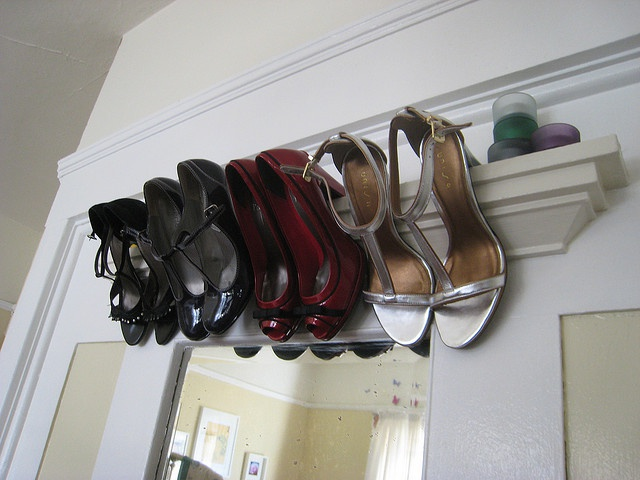Describe the objects in this image and their specific colors. I can see various objects in this image with different colors. 